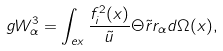Convert formula to latex. <formula><loc_0><loc_0><loc_500><loc_500>g W _ { \alpha } ^ { 3 } = \int _ { e x } \frac { f _ { i } ^ { 2 } ( x ) } { \tilde { u } } \Theta \tilde { r } r _ { \alpha } d \Omega ( x ) ,</formula> 